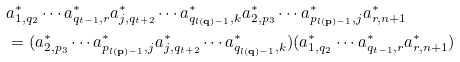Convert formula to latex. <formula><loc_0><loc_0><loc_500><loc_500>& a _ { 1 , q _ { 2 } } ^ { * } \cdots a _ { q _ { t - 1 } , r } ^ { * } a _ { j , q _ { t + 2 } } ^ { * } \cdots a _ { q _ { l ( \mathbf q ) - 1 } , k } ^ { * } a _ { 2 , p _ { 3 } } ^ { * } \cdots a _ { p _ { l ( \mathbf p ) - 1 } , j } ^ { * } a _ { r , n + 1 } ^ { * } \\ & = ( a _ { 2 , p _ { 3 } } ^ { * } \cdots a _ { p _ { l ( \mathbf p ) - 1 } , j } ^ { * } a _ { j , q _ { t + 2 } } ^ { * } \cdots a _ { q _ { l ( \mathbf q ) - 1 } , k } ^ { * } ) ( a _ { 1 , q _ { 2 } } ^ { * } \cdots a _ { q _ { t - 1 } , r } ^ { * } a _ { r , n + 1 } ^ { * } ) \\</formula> 